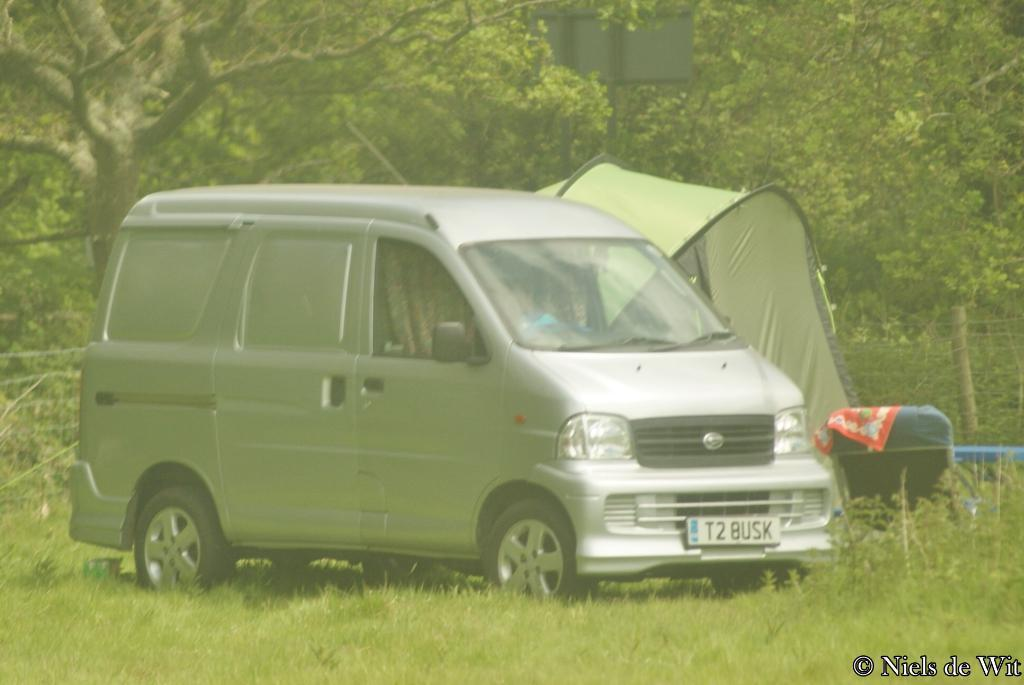<image>
Share a concise interpretation of the image provided. Silver car with the license plate T2BUSK parked on some grass. 